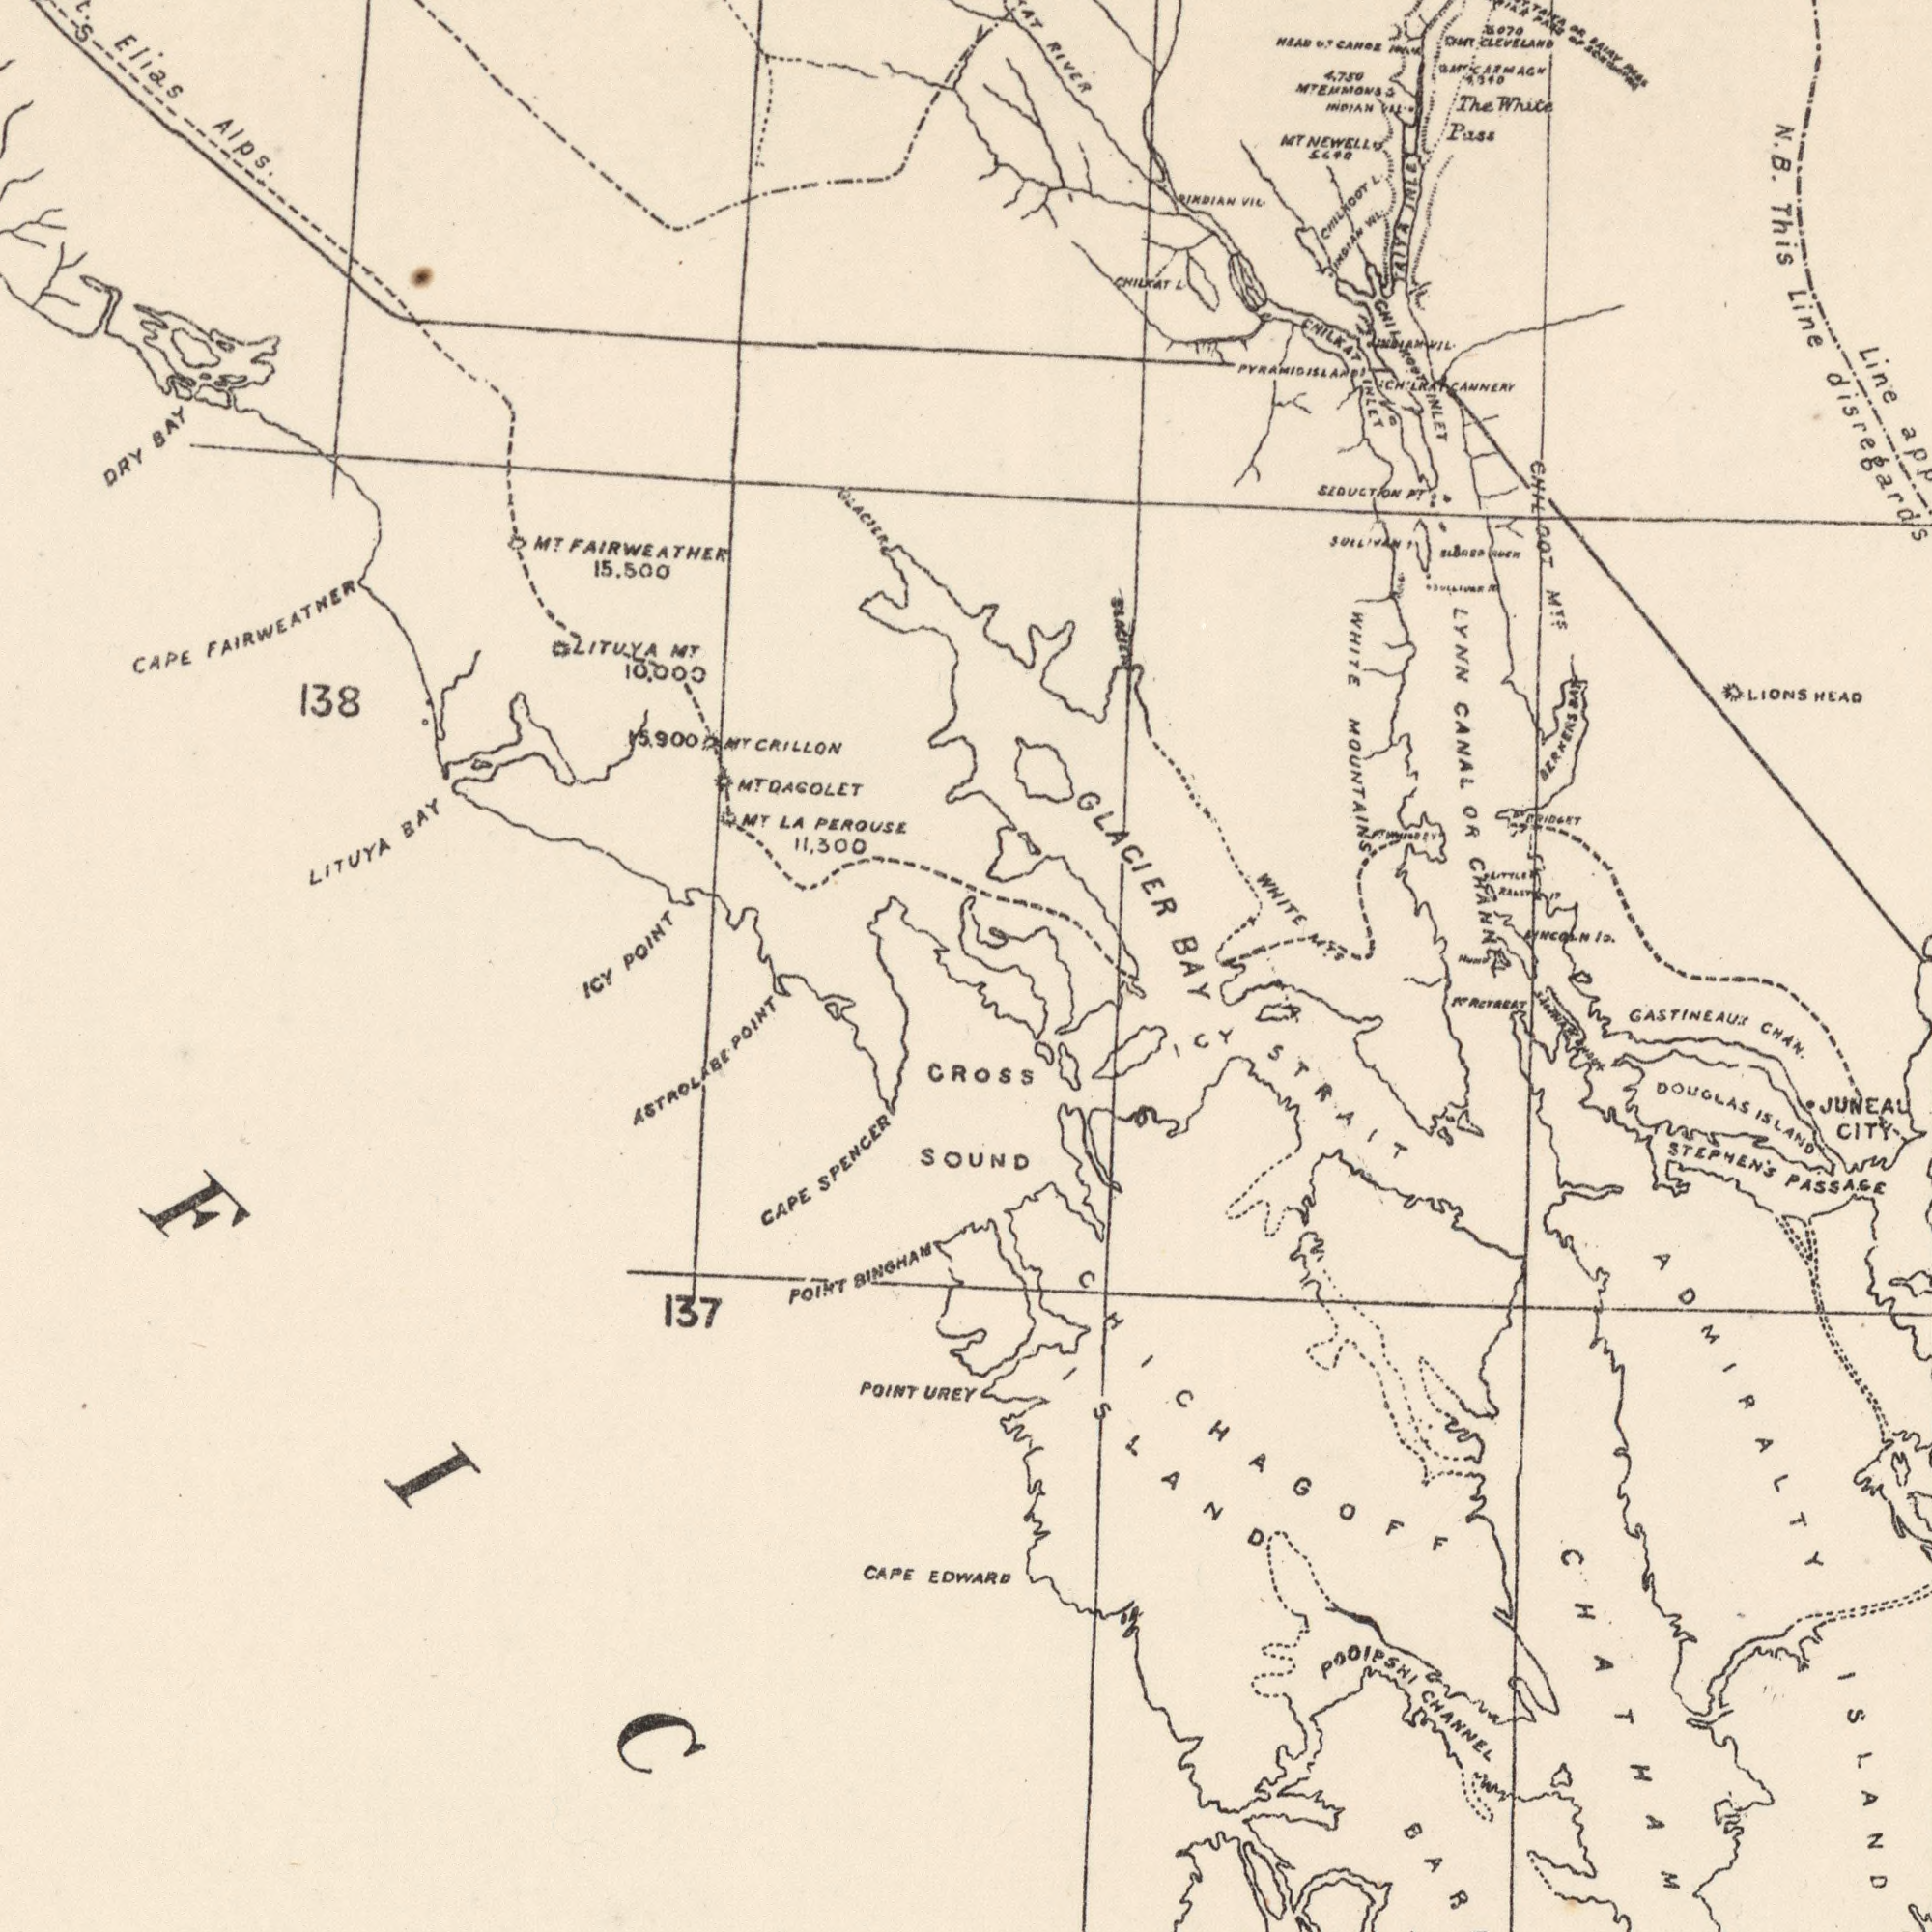What text is visible in the lower-right corner? BAY STEPHEN'S PASSAGE GASTINEAUX CHAN. ADMIRALTY ISLAND BAR ICY STRAIT CHICHAGOFF ISLAND DOUGLAS ISLAND JUNEAU CITY POOIPSHI CHANNEL PT RETREAT CHATHAM What text is visible in the upper-left corner? CAPE FAIRWEATHER MT FAIRWEATHER 15.500 Elias Alps. LITUYA BAY MT LA PEROUSE 11.300 138 DRY BAY MT DAGOLET POINT GLACIER LITUYA MT 10.000 15,900 MT CRILLON What text is shown in the top-right quadrant? GLACIER LYNN CANAL OR CHANNEL N.B. This Line disregards WHITE MTS The White Pass RIVER WHITE MOUNTAINS Line LIONS HEAD CHIL OOT MTF CHILKOOT L. SEDUCTION PT. AIYA INLET MT NEWELL INDIAN VIL. LINCOLN IS. CHILKAT INLET 4.750 MT EMMONS ###ARMAGH ###070 ###T CLEVELAND HEAD OF CANOE CHILKOOT INLET PT BRIDGET BERNERS BAY CHILKAT L. INDIAN VIL ###AMNI L. CHILKAT CANNERY RIVER PYRAMID ISLAND OR PASS PASS INDIAN VIL. SULLIVAN R. PT ###RY What text appears in the bottom-left area of the image? ICY CAPE SPENCER 137 POINT BINGHAM ASTROLABE POINT POINT UREY CAPE EDWARD CROSS SOUND ###FIC### 